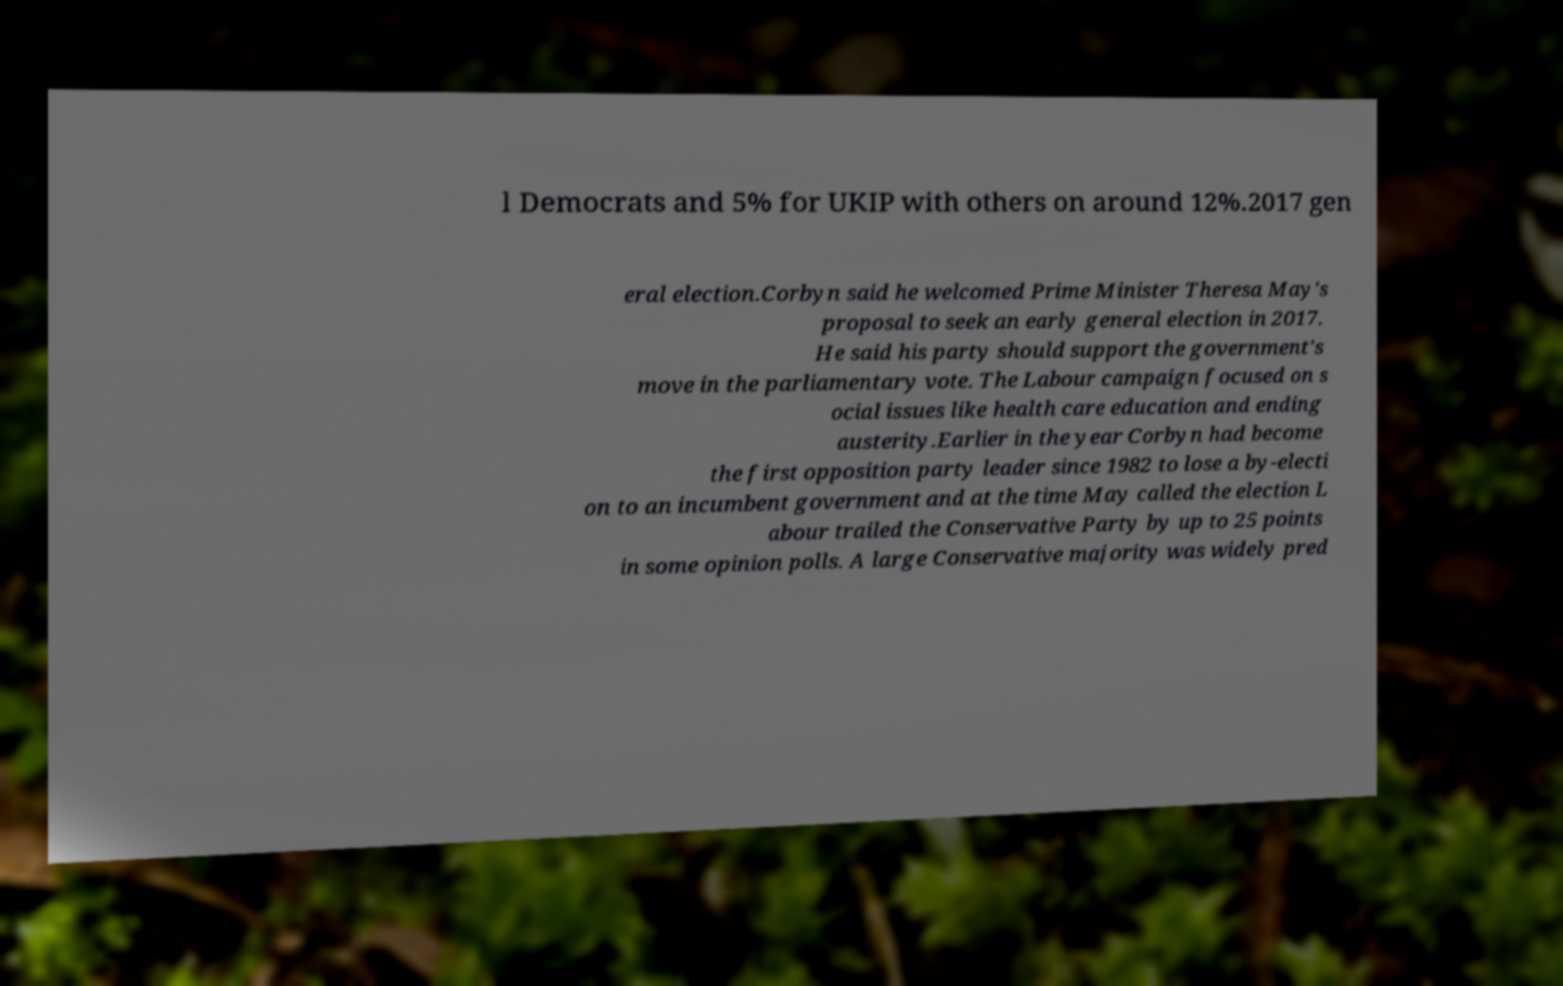I need the written content from this picture converted into text. Can you do that? l Democrats and 5% for UKIP with others on around 12%.2017 gen eral election.Corbyn said he welcomed Prime Minister Theresa May's proposal to seek an early general election in 2017. He said his party should support the government's move in the parliamentary vote. The Labour campaign focused on s ocial issues like health care education and ending austerity.Earlier in the year Corbyn had become the first opposition party leader since 1982 to lose a by-electi on to an incumbent government and at the time May called the election L abour trailed the Conservative Party by up to 25 points in some opinion polls. A large Conservative majority was widely pred 